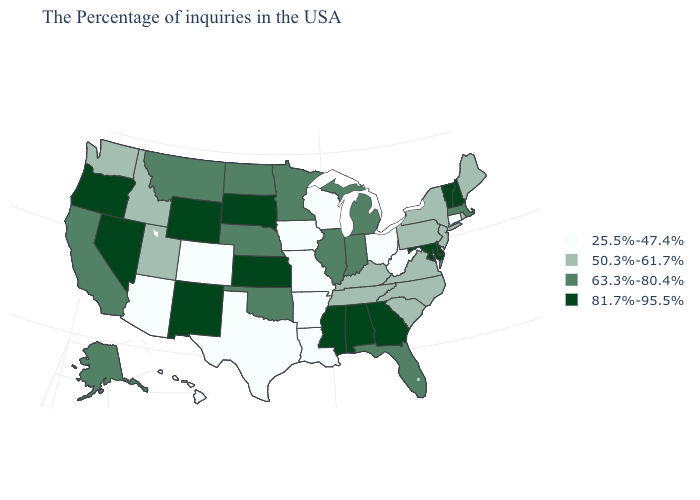How many symbols are there in the legend?
Short answer required. 4. What is the value of Indiana?
Be succinct. 63.3%-80.4%. What is the lowest value in the West?
Give a very brief answer. 25.5%-47.4%. Does Wisconsin have the lowest value in the USA?
Be succinct. Yes. What is the value of New Hampshire?
Give a very brief answer. 81.7%-95.5%. Does the first symbol in the legend represent the smallest category?
Be succinct. Yes. What is the value of Kentucky?
Give a very brief answer. 50.3%-61.7%. What is the value of Tennessee?
Be succinct. 50.3%-61.7%. What is the value of California?
Quick response, please. 63.3%-80.4%. What is the value of Utah?
Write a very short answer. 50.3%-61.7%. What is the highest value in the South ?
Short answer required. 81.7%-95.5%. What is the value of California?
Concise answer only. 63.3%-80.4%. Among the states that border North Dakota , which have the lowest value?
Concise answer only. Minnesota, Montana. What is the lowest value in the West?
Give a very brief answer. 25.5%-47.4%. Does Michigan have a lower value than Mississippi?
Concise answer only. Yes. 